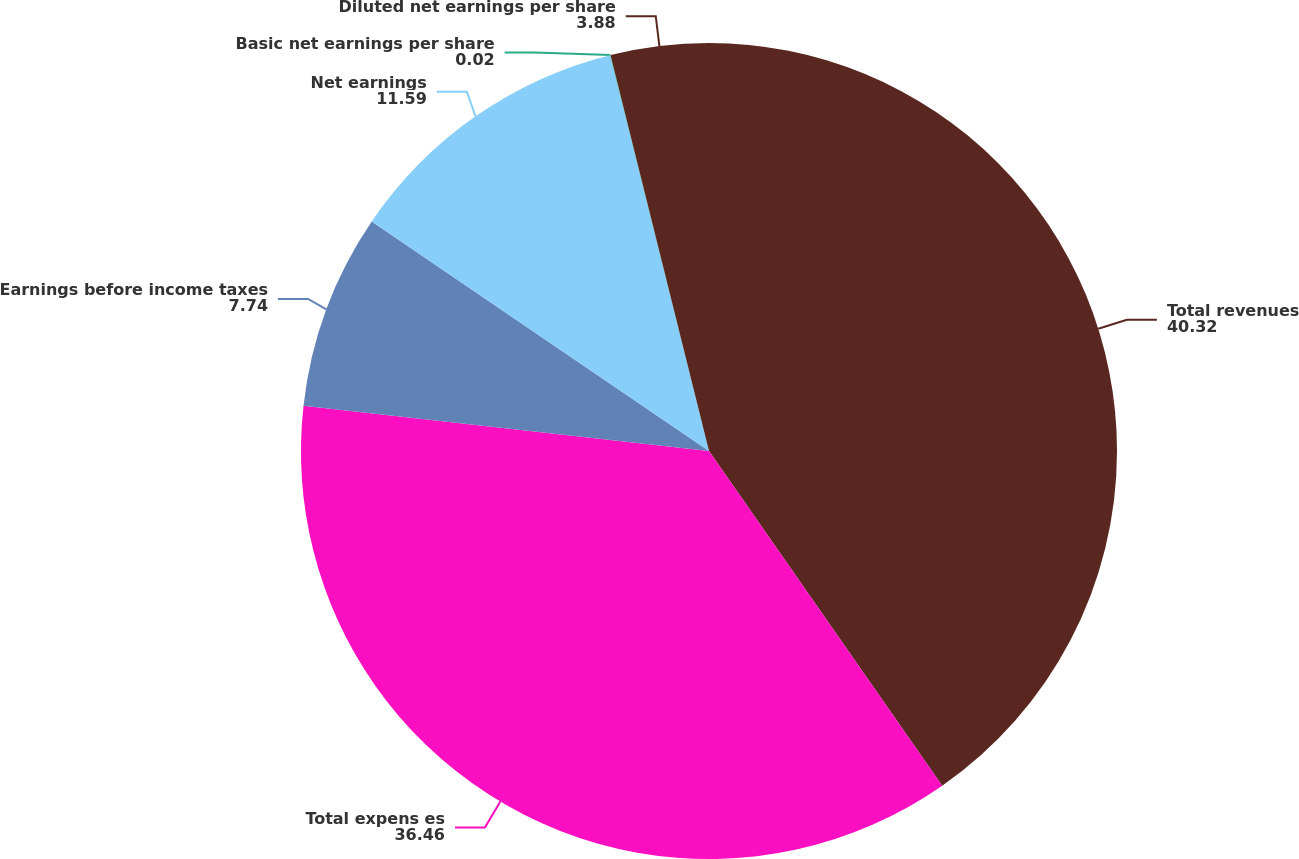<chart> <loc_0><loc_0><loc_500><loc_500><pie_chart><fcel>Total revenues<fcel>Total expens es<fcel>Earnings before income taxes<fcel>Net earnings<fcel>Basic net earnings per share<fcel>Diluted net earnings per share<nl><fcel>40.32%<fcel>36.46%<fcel>7.74%<fcel>11.59%<fcel>0.02%<fcel>3.88%<nl></chart> 